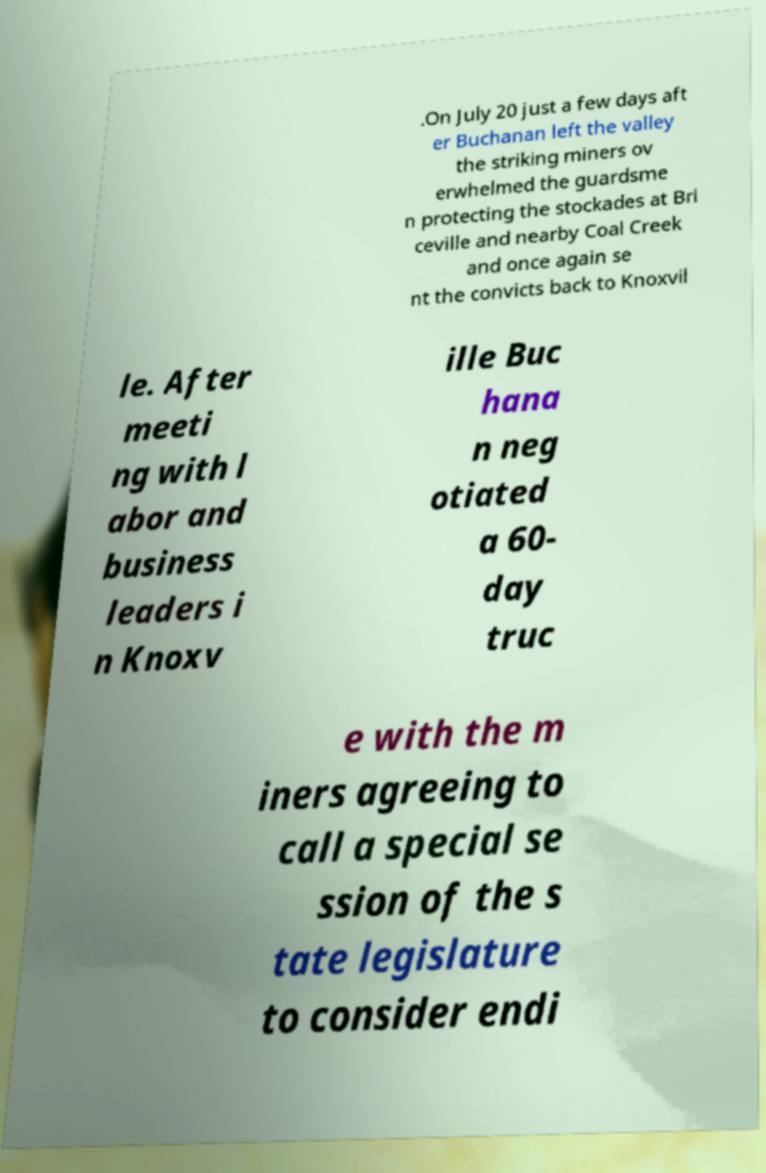Please identify and transcribe the text found in this image. .On July 20 just a few days aft er Buchanan left the valley the striking miners ov erwhelmed the guardsme n protecting the stockades at Bri ceville and nearby Coal Creek and once again se nt the convicts back to Knoxvil le. After meeti ng with l abor and business leaders i n Knoxv ille Buc hana n neg otiated a 60- day truc e with the m iners agreeing to call a special se ssion of the s tate legislature to consider endi 